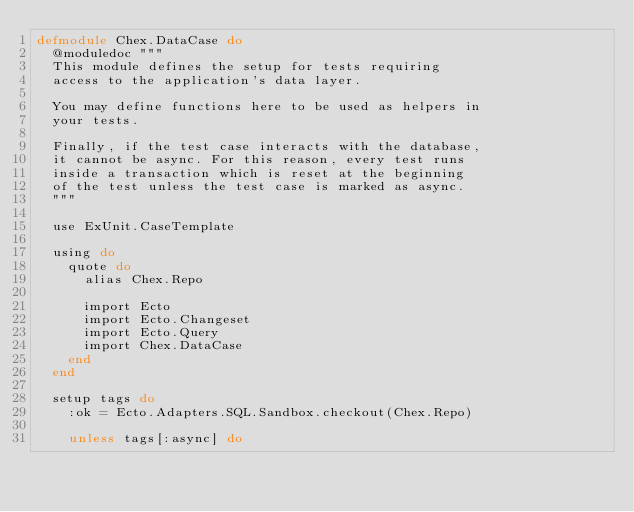Convert code to text. <code><loc_0><loc_0><loc_500><loc_500><_Elixir_>defmodule Chex.DataCase do
  @moduledoc """
  This module defines the setup for tests requiring
  access to the application's data layer.

  You may define functions here to be used as helpers in
  your tests.

  Finally, if the test case interacts with the database,
  it cannot be async. For this reason, every test runs
  inside a transaction which is reset at the beginning
  of the test unless the test case is marked as async.
  """

  use ExUnit.CaseTemplate

  using do
    quote do
      alias Chex.Repo

      import Ecto
      import Ecto.Changeset
      import Ecto.Query
      import Chex.DataCase
    end
  end

  setup tags do
    :ok = Ecto.Adapters.SQL.Sandbox.checkout(Chex.Repo)

    unless tags[:async] do</code> 